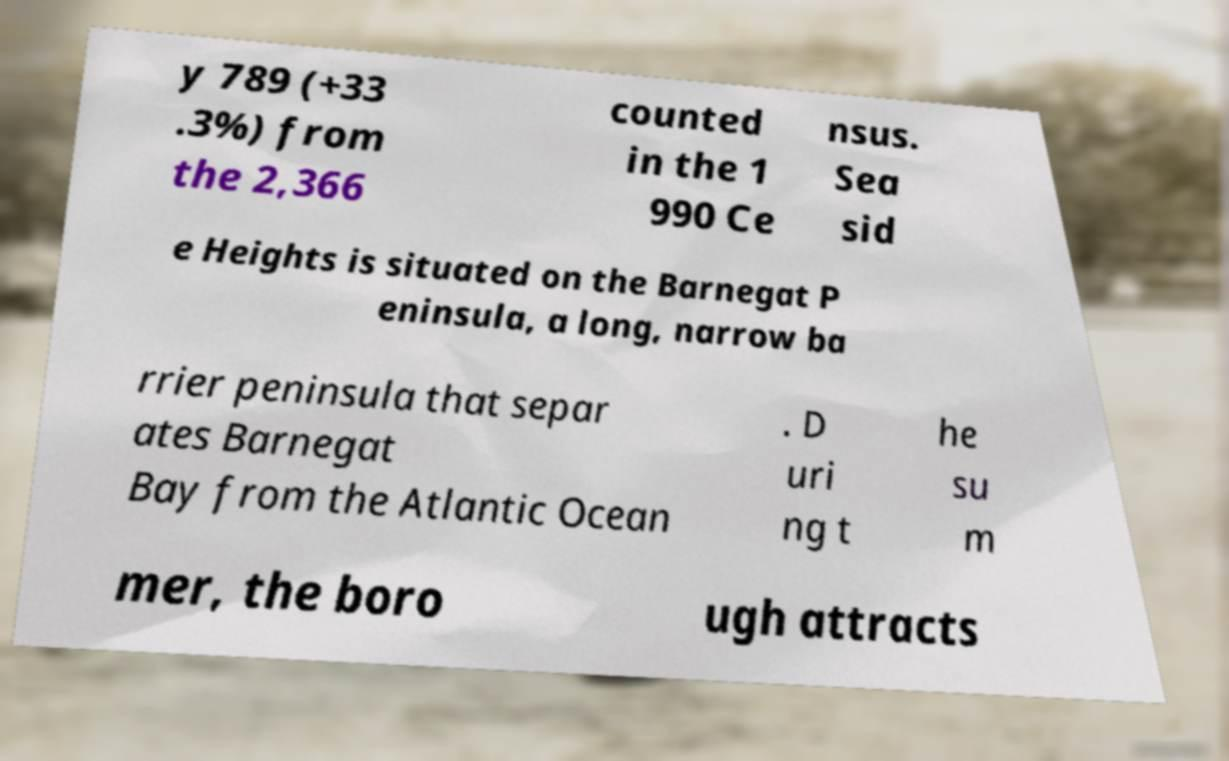What messages or text are displayed in this image? I need them in a readable, typed format. y 789 (+33 .3%) from the 2,366 counted in the 1 990 Ce nsus. Sea sid e Heights is situated on the Barnegat P eninsula, a long, narrow ba rrier peninsula that separ ates Barnegat Bay from the Atlantic Ocean . D uri ng t he su m mer, the boro ugh attracts 